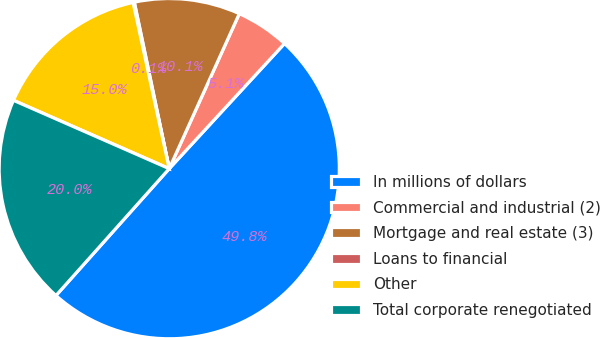Convert chart to OTSL. <chart><loc_0><loc_0><loc_500><loc_500><pie_chart><fcel>In millions of dollars<fcel>Commercial and industrial (2)<fcel>Mortgage and real estate (3)<fcel>Loans to financial<fcel>Other<fcel>Total corporate renegotiated<nl><fcel>49.75%<fcel>5.09%<fcel>10.05%<fcel>0.12%<fcel>15.01%<fcel>19.98%<nl></chart> 